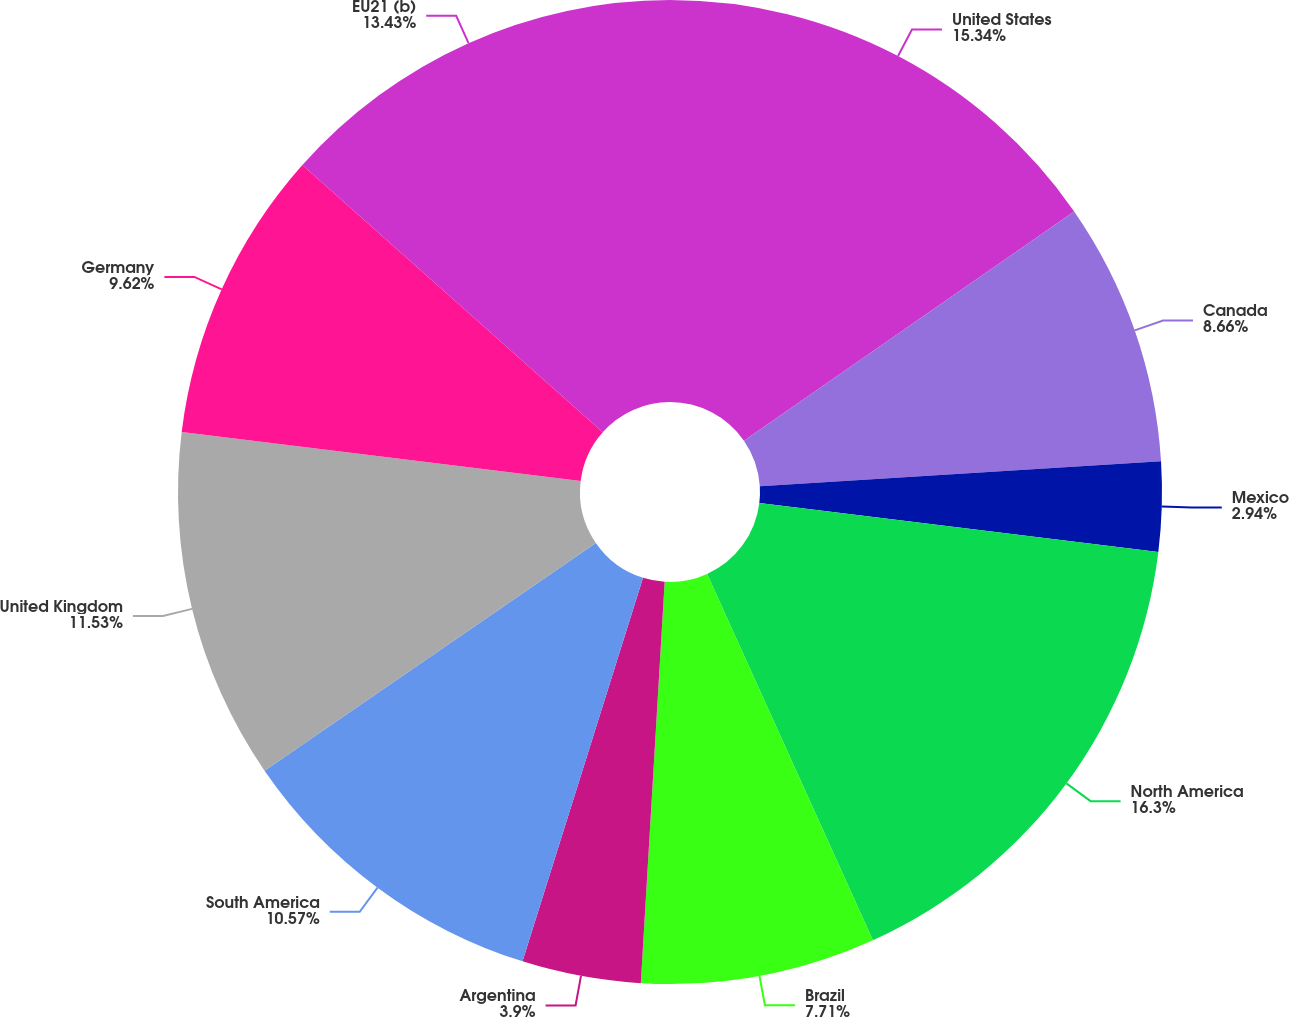Convert chart to OTSL. <chart><loc_0><loc_0><loc_500><loc_500><pie_chart><fcel>United States<fcel>Canada<fcel>Mexico<fcel>North America<fcel>Brazil<fcel>Argentina<fcel>South America<fcel>United Kingdom<fcel>Germany<fcel>EU21 (b)<nl><fcel>15.34%<fcel>8.66%<fcel>2.94%<fcel>16.29%<fcel>7.71%<fcel>3.9%<fcel>10.57%<fcel>11.53%<fcel>9.62%<fcel>13.43%<nl></chart> 